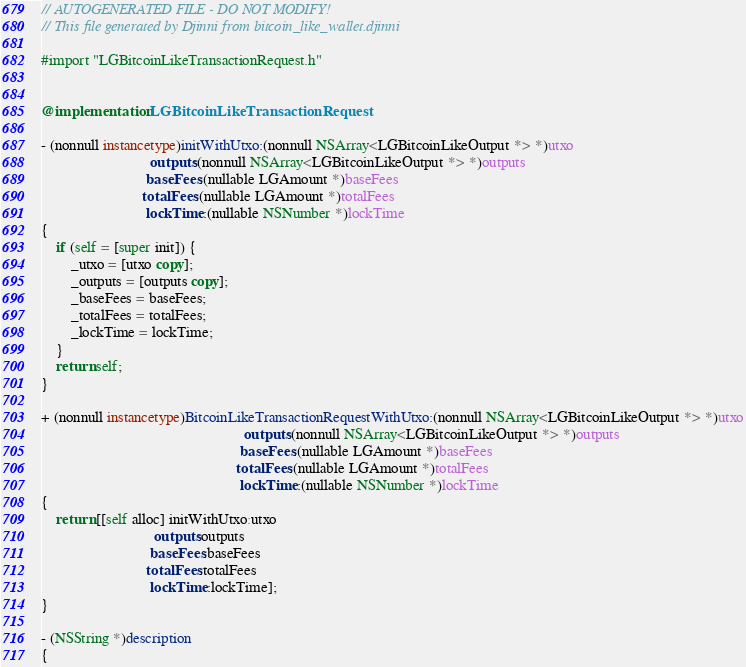<code> <loc_0><loc_0><loc_500><loc_500><_ObjectiveC_>// AUTOGENERATED FILE - DO NOT MODIFY!
// This file generated by Djinni from bitcoin_like_wallet.djinni

#import "LGBitcoinLikeTransactionRequest.h"


@implementation LGBitcoinLikeTransactionRequest

- (nonnull instancetype)initWithUtxo:(nonnull NSArray<LGBitcoinLikeOutput *> *)utxo
                             outputs:(nonnull NSArray<LGBitcoinLikeOutput *> *)outputs
                            baseFees:(nullable LGAmount *)baseFees
                           totalFees:(nullable LGAmount *)totalFees
                            lockTime:(nullable NSNumber *)lockTime
{
    if (self = [super init]) {
        _utxo = [utxo copy];
        _outputs = [outputs copy];
        _baseFees = baseFees;
        _totalFees = totalFees;
        _lockTime = lockTime;
    }
    return self;
}

+ (nonnull instancetype)BitcoinLikeTransactionRequestWithUtxo:(nonnull NSArray<LGBitcoinLikeOutput *> *)utxo
                                                      outputs:(nonnull NSArray<LGBitcoinLikeOutput *> *)outputs
                                                     baseFees:(nullable LGAmount *)baseFees
                                                    totalFees:(nullable LGAmount *)totalFees
                                                     lockTime:(nullable NSNumber *)lockTime
{
    return [[self alloc] initWithUtxo:utxo
                              outputs:outputs
                             baseFees:baseFees
                            totalFees:totalFees
                             lockTime:lockTime];
}

- (NSString *)description
{</code> 